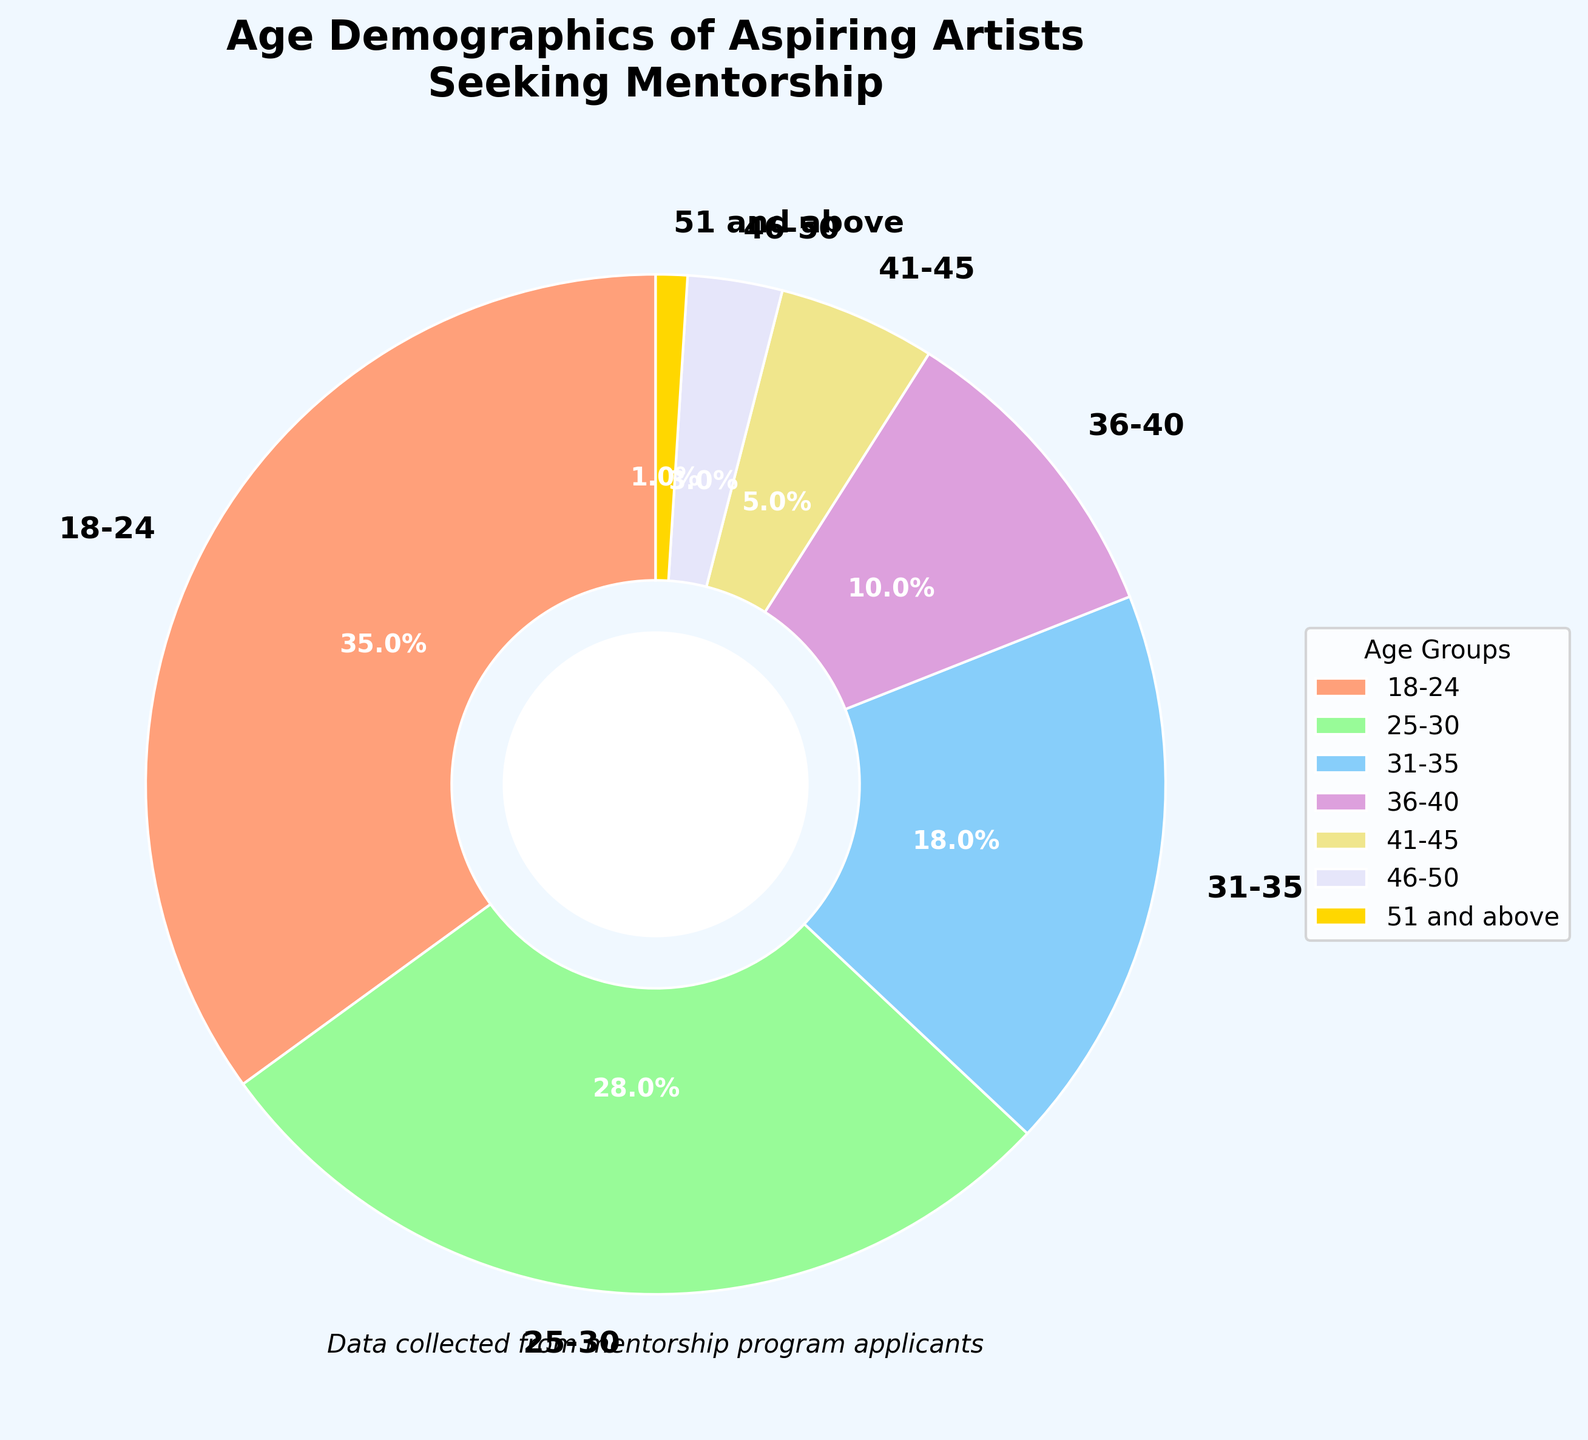What's the most common age group among aspiring artists seeking mentorship? The most common age group among aspiring artists seeking mentorship is identified by looking at the segment with the largest percentage. The 18-24 age group has the largest percentage, 35%.
Answer: 18-24 How many age groups have less than 10% of aspiring artists? By examining the pie chart, we can see that the age groups 41-45, 46-50, and 51 and above each have a percentage lower than 10%. There are 3 age groups each with less than 10%.
Answer: 3 Which age group is exactly in the middle in terms of percentage? To find the middle age group, sort the percentages in ascending order: 1%, 3%, 5%, 10%, 18%, 28%, 35%. The middle value here is 10%, which corresponds to the 36-40 age group.
Answer: 36-40 What's the total percentage of artists aged 31 and above? To find the total percentage of artists aged 31 and above, add the percentages of the relevant age groups: 18% (31-35), 10% (36-40), 5% (41-45), 3% (46-50), and 1% (51 and above). 18% + 10% + 5% + 3% + 1% = 37%.
Answer: 37% How much more common is the 18-24 age group than the 46-50 age group? The percentage of the 18-24 age group is 35%, and the percentage of the 46-50 age group is 3%. The difference is 35% - 3% = 32%.
Answer: 32% Which segment has the light purple color in the pie chart? The segment with the light purple color corresponds to the 31-35 age group, as identified by the legend and the color matching to the segment.
Answer: 31-35 What is the combined percentage of the two largest age groups? The two largest age groups are 18-24 (35%) and 25-30 (28%). The combined percentage is 35% + 28% = 63%.
Answer: 63% Do the 25-30 and 31-35 age groups together make up more than half the total percentage? The percentage of the 25-30 age group is 28%, and the percentage of the 31-35 age group is 18%. Adding these, 28% + 18% = 46%, which is less than 50%.
Answer: No 